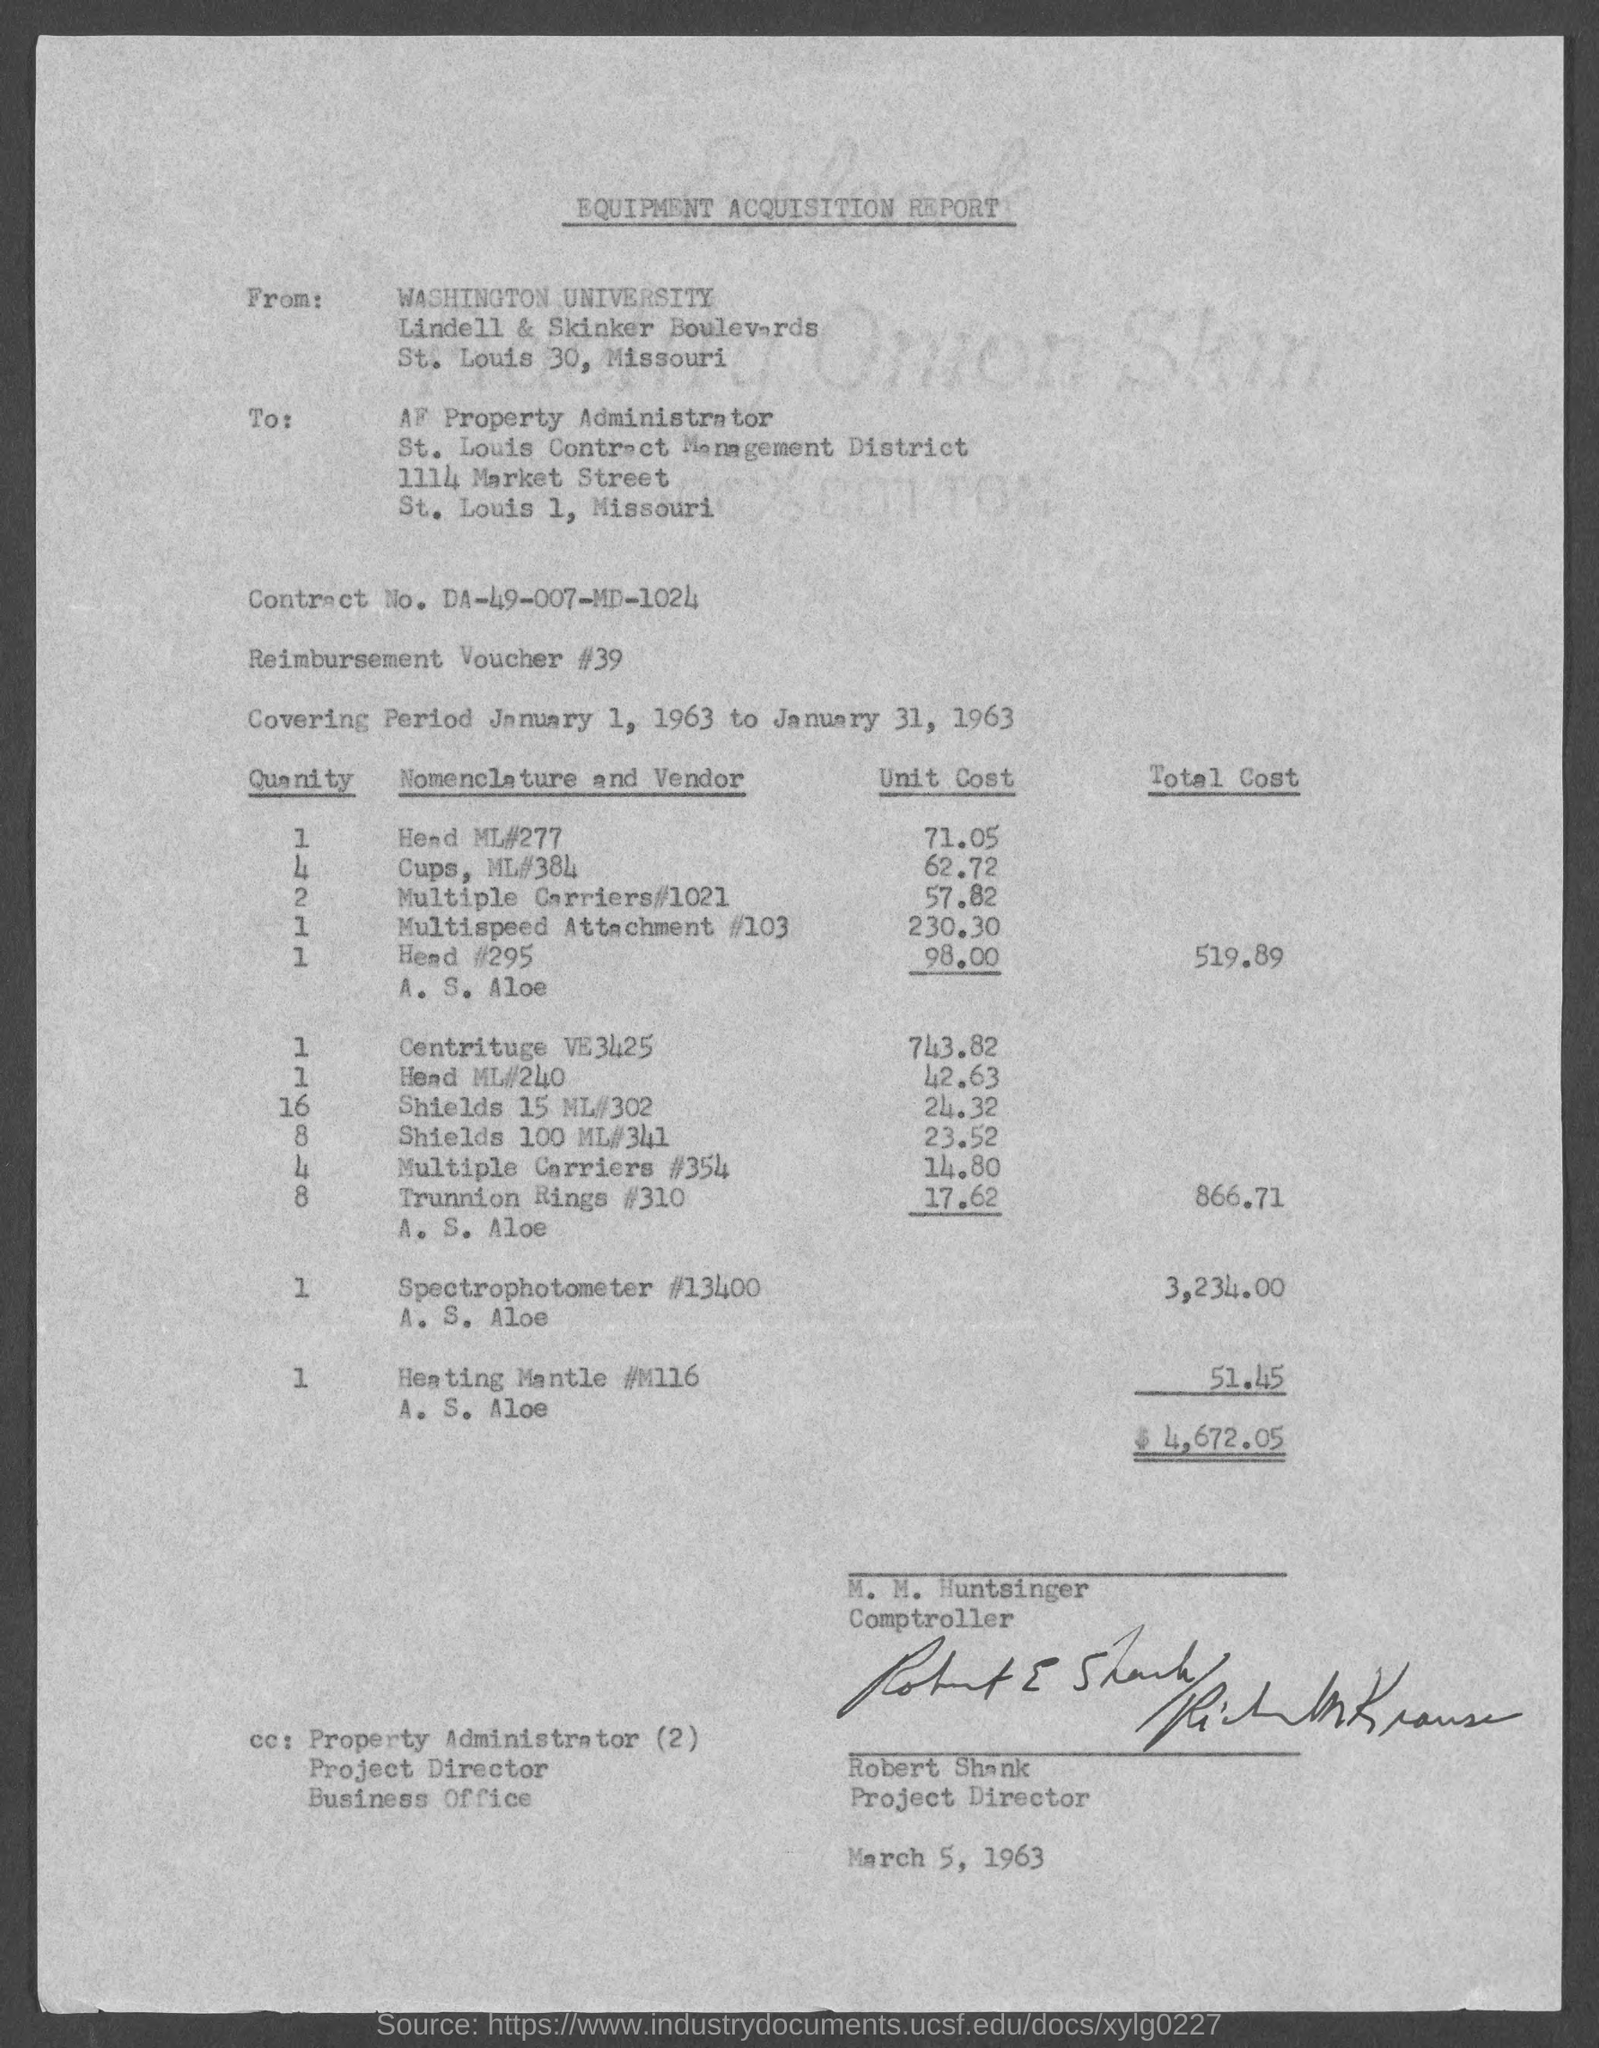Identify some key points in this picture. The contract number is DA-49-007-MD-1024. The heading of the page is 'Equipment Acquisition Report.' Robert Shank holds the position of Project Director. M. M. Huntsinger holds the position of Comptroller. The AF property administrator is located in the state of Missouri. 